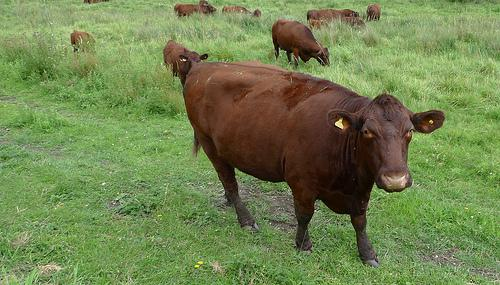Paint a vivid picture of the scene depicted in the image using descriptive language. In the verdant expanse of the grassland, a herd of majestic brown cattle graze leisurely, their ears adorned with yellow tags, surrounded by ephemeral yellow blossoms and patches of exposed earth. Using metaphorical language, describe the primary subjects and actions in the image. In a sea of greenery, a symphony of earth-toned cows partake in nature's abundant feast, their ears marked by sun-kissed badges while pools of soil and sunflower-hued petals embellish the serene landscape. Give a concise summary of the scene in the image using simple language. Brown cows are eating grass in a field. They have yellow tags on their ears. There are yellow flowers and dirt patches on the ground. Express the content of the image by highlighting the key subjects and scene. An idyllic scene unfolds as brown cows graze leisurely in a verdant meadow, donning yellow tags in their ears, and dappled in the rich hues of scattered flowers and earth patches. Describe the photograph as though it were a postcard. Greetings from the picturesque countryside, where brown cows delightfully graze amidst rolling fields of verdant grass, adorned with vibrant yellow flowers, offering an idyllic, tranquil scene. Explain the primary subject of the image and what is happening. The main subject of the image is a herd of brown cows. They are grazing in a grassy field with yellow tags in their ears, along with some yellow flowers and dirt patches in the vicinity. Write a short story inspired by the image. On a warm, sunny day in the countryside, a charming and peaceful gathering of brown cows enjoyed nibbling on the lush grass, with splashes of yellow flowers dotting the open field and a happy camaraderie shared among the bovine companions. Provide a brief summary of the visible objects and activity in the image. A herd of brown cows are grazing in a grassy field, with some having yellow tags in their ears, and dirt patches and yellow flowers on the ground. Describe the image as if you were talking to a person with a visual impairment. Imagine a peaceful scene filled with brown cows grazing on grass in an open field. The cows have yellow tags attached to their ears, and there are small yellow flowers and dirt patches scattered throughout the field. What are the main features and activity happening in the image? A group of brown cows are grazing on grass in a field, and they have yellow tags in their ears. There are also yellow flowers and dirt patches nearby. 